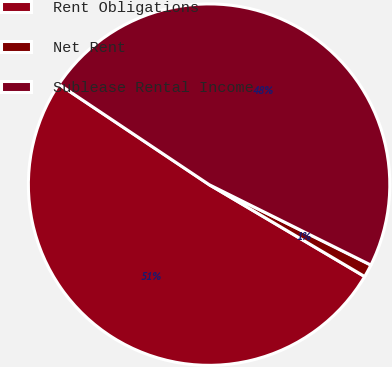<chart> <loc_0><loc_0><loc_500><loc_500><pie_chart><fcel>Rent Obligations<fcel>Net Rent<fcel>Sublease Rental Income<nl><fcel>50.88%<fcel>1.15%<fcel>47.97%<nl></chart> 